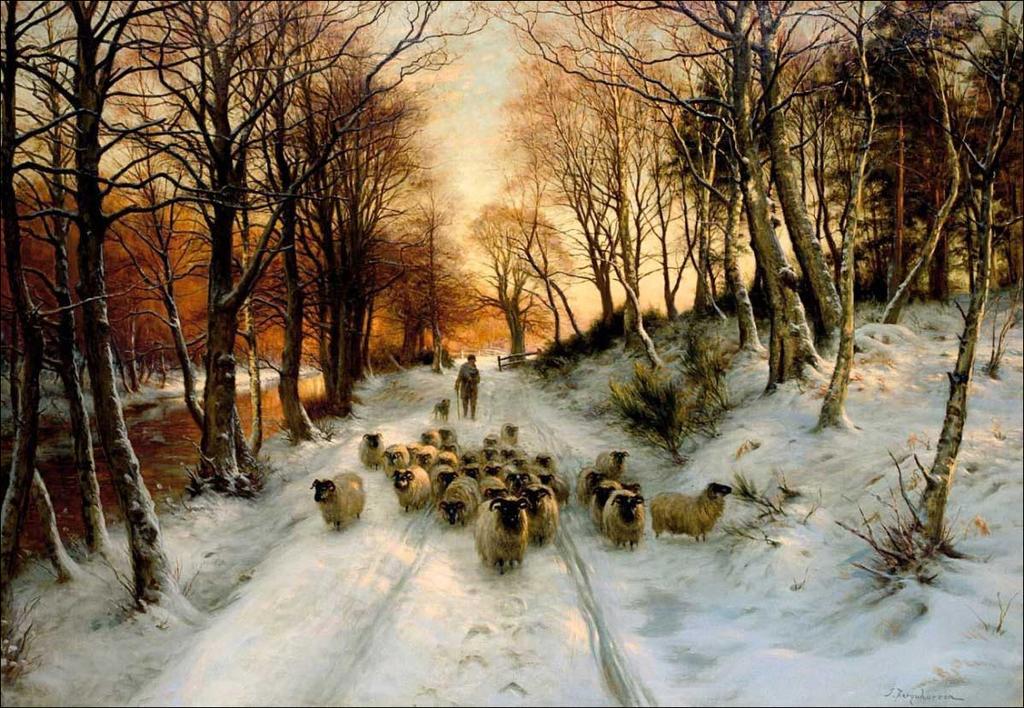Describe this image in one or two sentences. This is an edited image. At the bottom, we see the snow. In the middle, we see the sheep. We see a man is standing and he is holding a stick in his hand. On either side of the picture, we see the trees. There are trees and the sky in the background. 